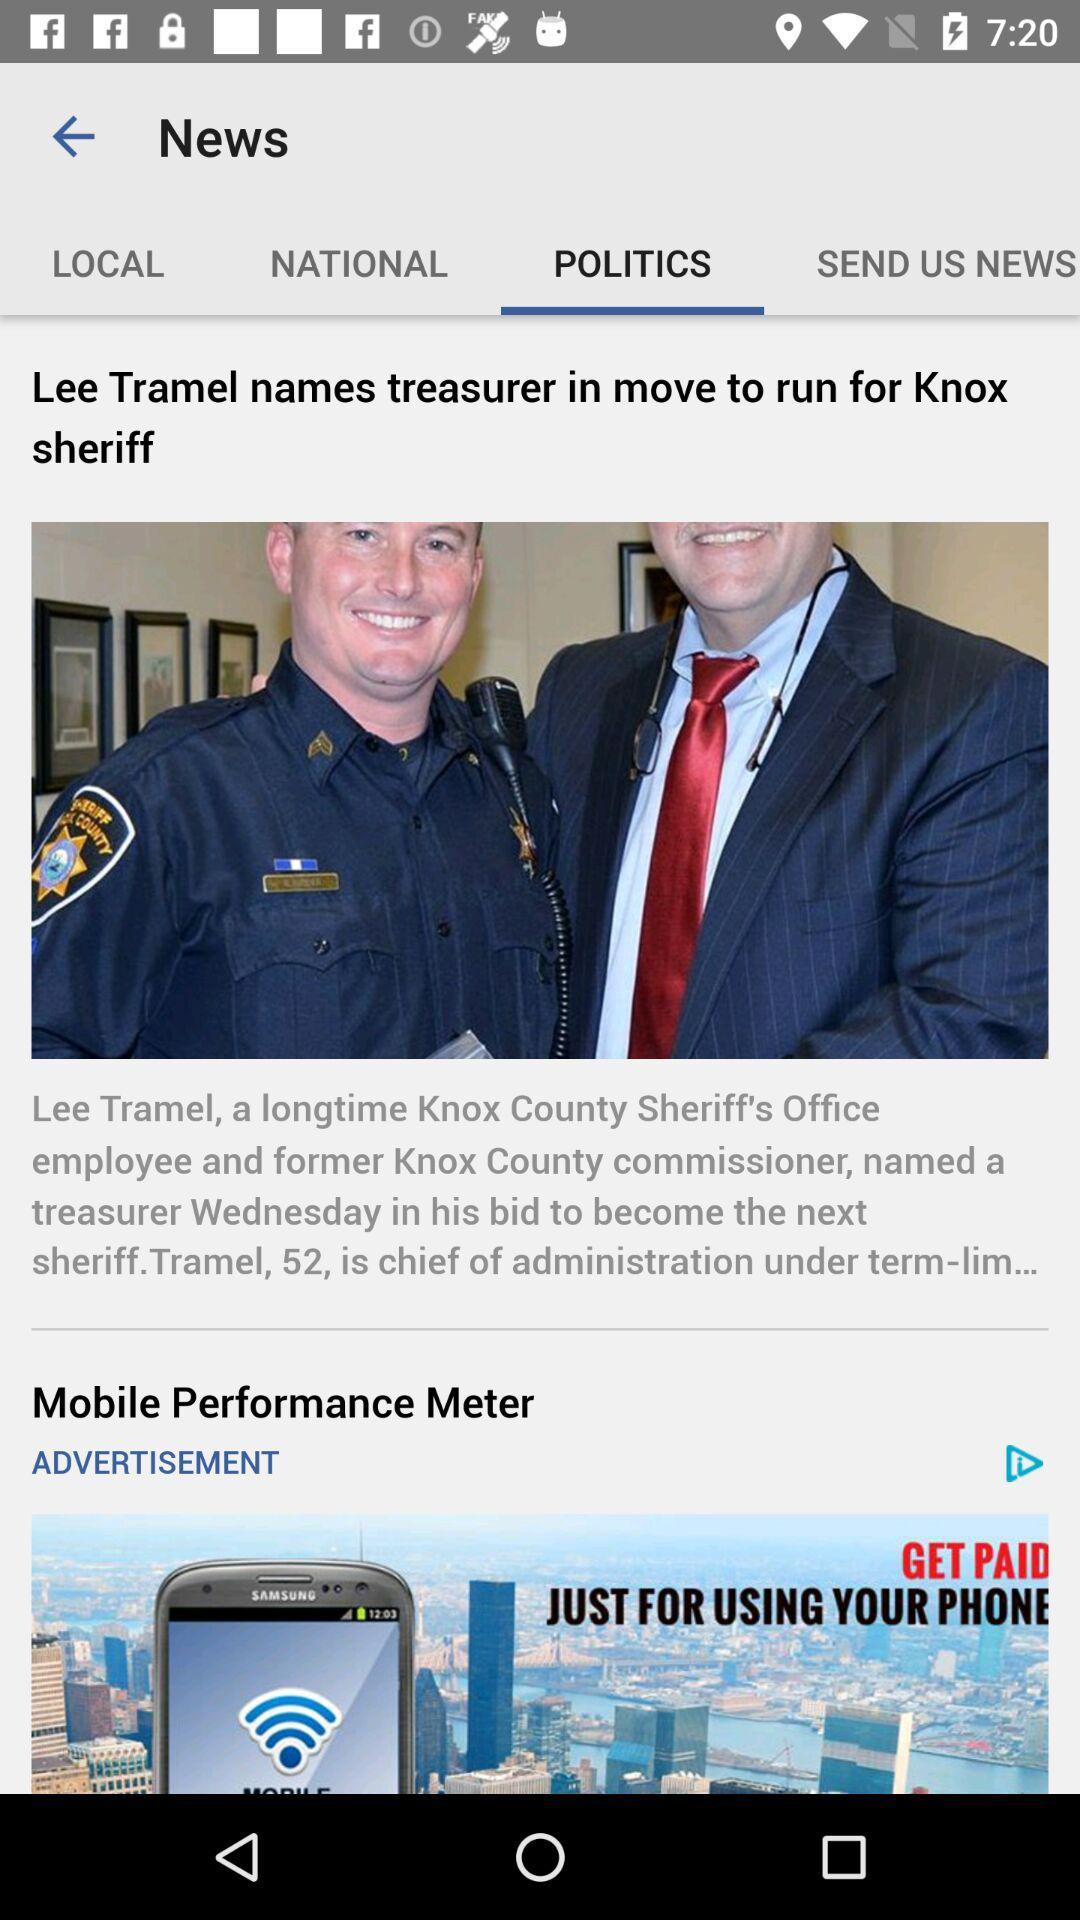When was "Lee Tramel names treasurer in move to run for Knox sheriff" published?
When the provided information is insufficient, respond with <no answer>. <no answer> 